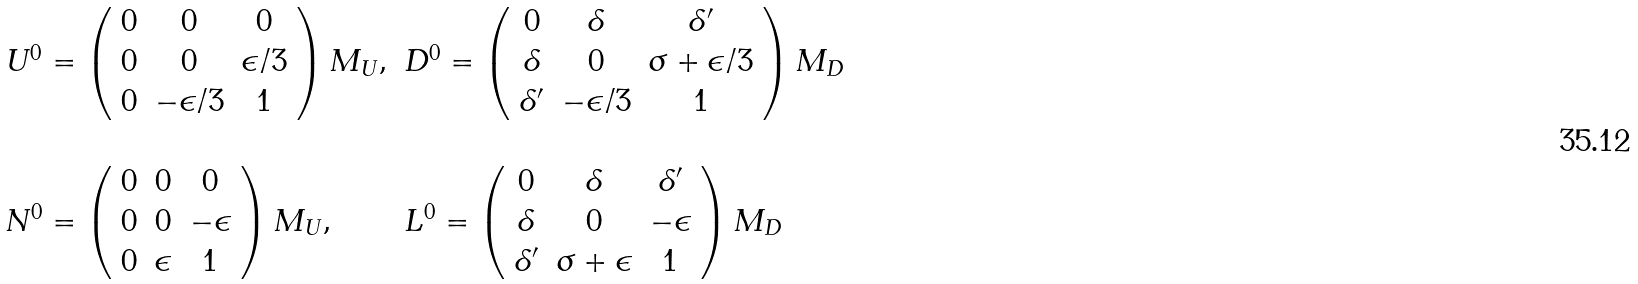Convert formula to latex. <formula><loc_0><loc_0><loc_500><loc_500>\begin{array} { l l } U ^ { 0 } = \left ( \begin{array} { c c c } 0 & 0 & 0 \\ 0 & 0 & \epsilon / 3 \\ 0 & - \epsilon / 3 & 1 \end{array} \right ) M _ { U } , & D ^ { 0 } = \left ( \begin{array} { c c c } 0 & \delta & \delta ^ { \prime } \\ \delta & 0 & \sigma + \epsilon / 3 \\ \delta ^ { \prime } & - \epsilon / 3 & 1 \end{array} \right ) M _ { D } \\ & \\ N ^ { 0 } = \left ( \begin{array} { c c c } 0 & 0 & 0 \\ 0 & 0 & - \epsilon \\ 0 & \epsilon & 1 \end{array} \right ) M _ { U } , & L ^ { 0 } = \left ( \begin{array} { c c c } 0 & \delta & \delta ^ { \prime } \\ \delta & 0 & - \epsilon \\ \delta ^ { \prime } & \sigma + \epsilon & 1 \end{array} \right ) M _ { D } \end{array}</formula> 